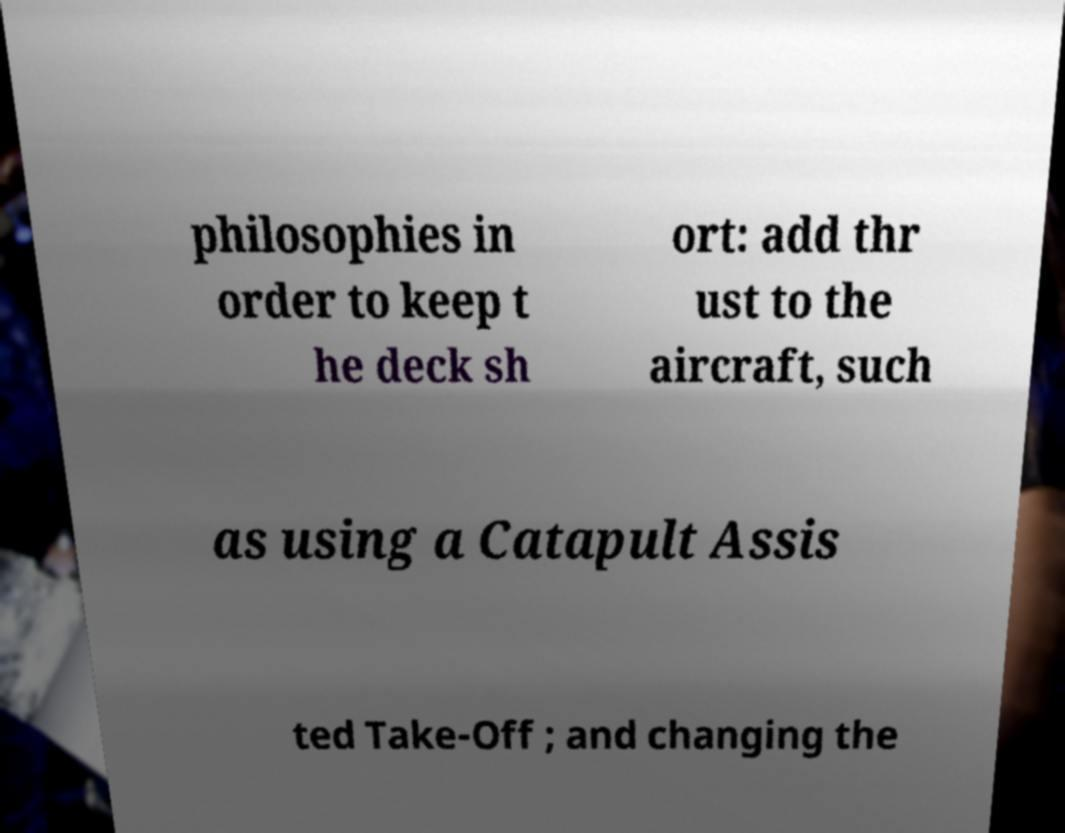Can you read and provide the text displayed in the image?This photo seems to have some interesting text. Can you extract and type it out for me? philosophies in order to keep t he deck sh ort: add thr ust to the aircraft, such as using a Catapult Assis ted Take-Off ; and changing the 